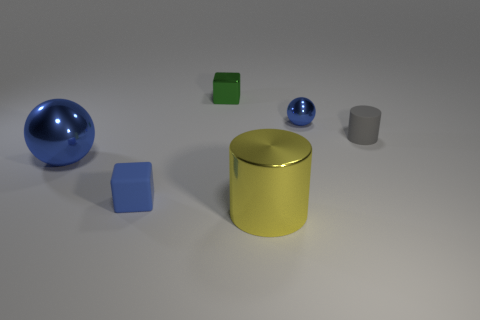How many large things are either green things or cubes?
Make the answer very short. 0. Is there a blue thing that has the same shape as the small gray matte thing?
Keep it short and to the point. No. Is the tiny gray thing the same shape as the tiny green metal thing?
Offer a very short reply. No. There is a tiny block that is behind the matte block behind the big cylinder; what color is it?
Keep it short and to the point. Green. There is a metal thing that is the same size as the yellow shiny cylinder; what is its color?
Your answer should be very brief. Blue. How many metallic things are either big brown spheres or blue things?
Your response must be concise. 2. There is a small gray object that is to the right of the big metallic cylinder; what number of matte things are in front of it?
Your answer should be very brief. 1. What size is the cube that is the same color as the large ball?
Your response must be concise. Small. How many things are tiny green blocks or tiny cubes in front of the tiny blue ball?
Give a very brief answer. 2. Are there any large things made of the same material as the large blue sphere?
Your answer should be compact. Yes. 